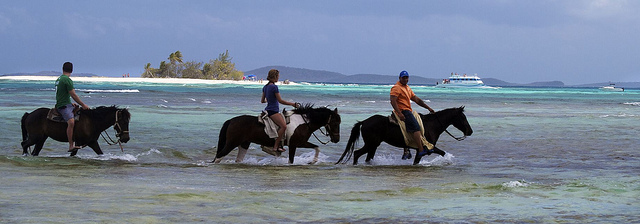What activity are the people engaged in? The people in the image are engaged in horseback riding, specifically equestrian activities conducted in shallow waters along the beach, which is a unique and delightful experience often enjoyed in tropical destinations. 